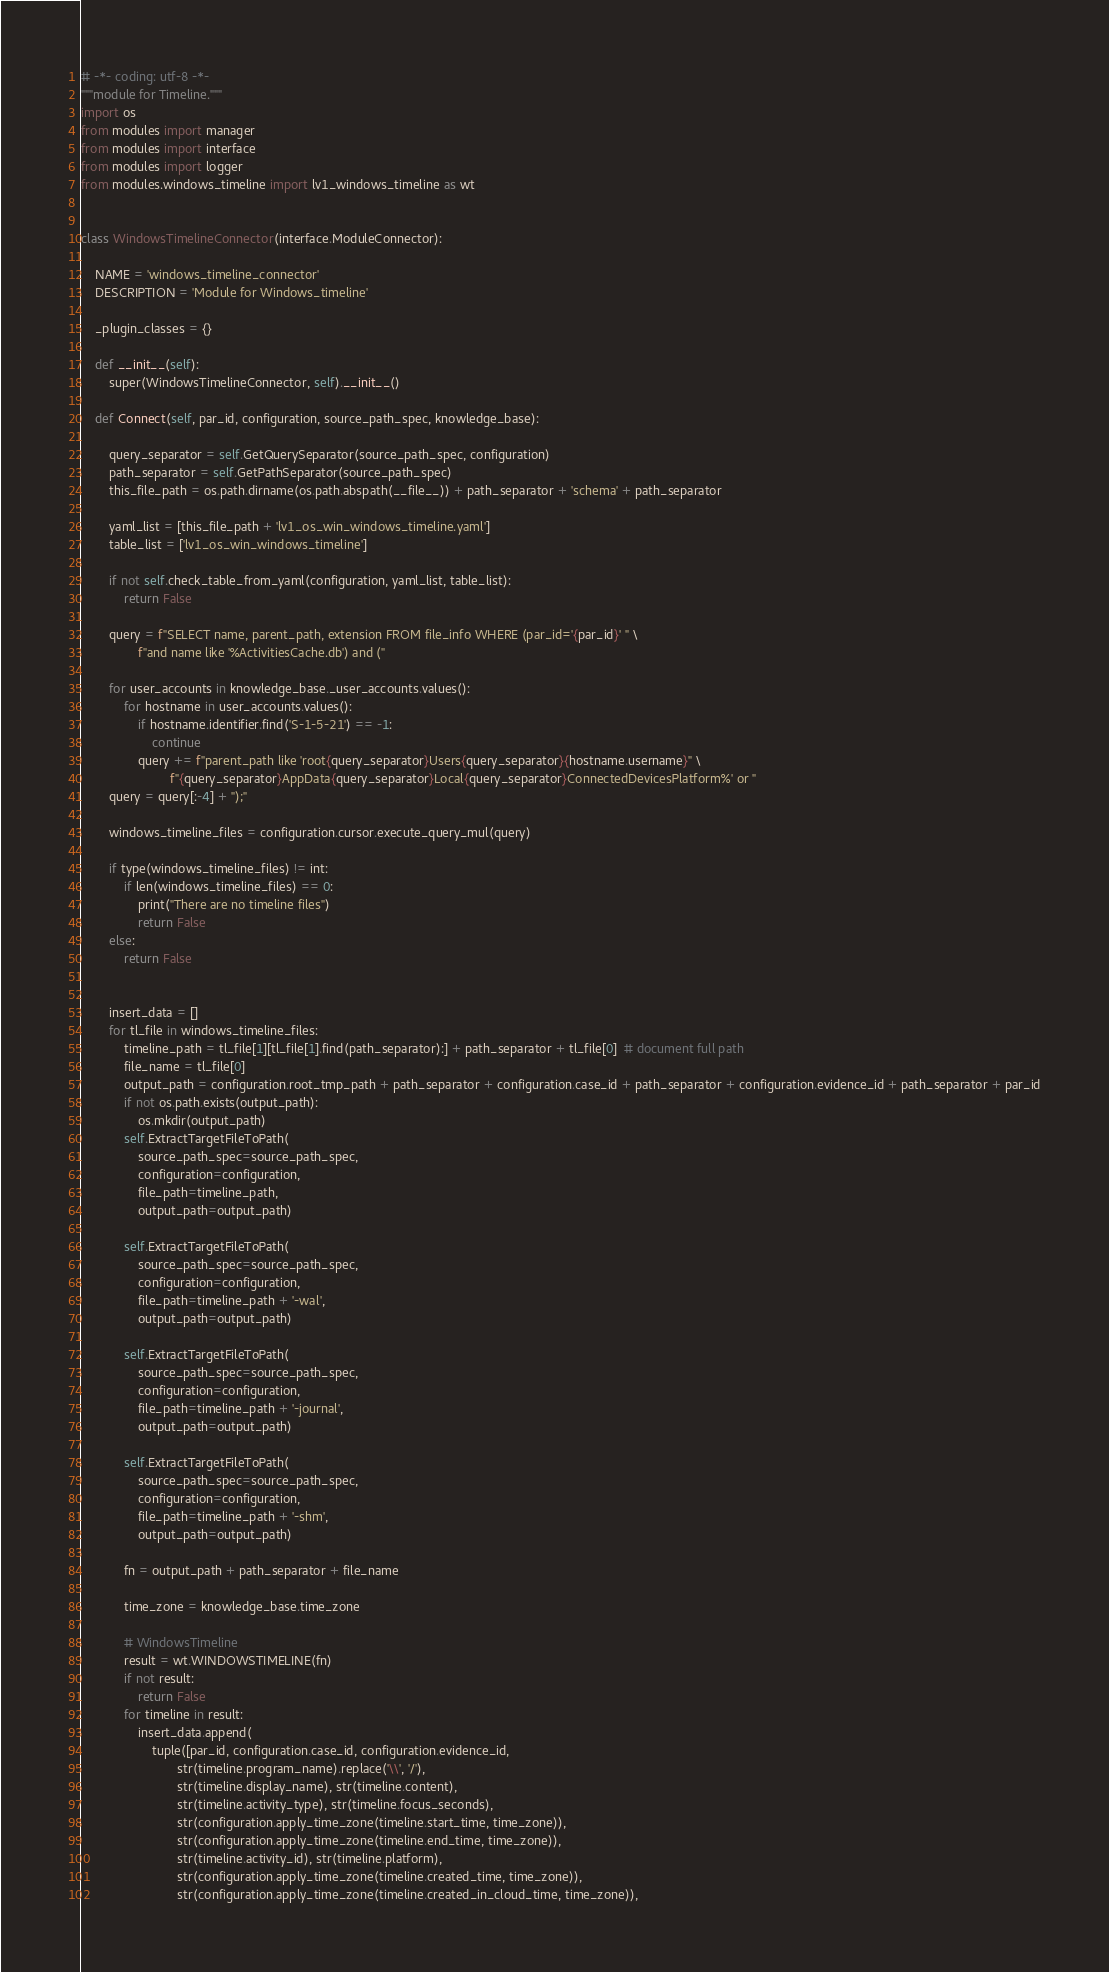Convert code to text. <code><loc_0><loc_0><loc_500><loc_500><_Python_># -*- coding: utf-8 -*-
"""module for Timeline."""
import os
from modules import manager
from modules import interface
from modules import logger
from modules.windows_timeline import lv1_windows_timeline as wt


class WindowsTimelineConnector(interface.ModuleConnector):

    NAME = 'windows_timeline_connector'
    DESCRIPTION = 'Module for Windows_timeline'

    _plugin_classes = {}

    def __init__(self):
        super(WindowsTimelineConnector, self).__init__()

    def Connect(self, par_id, configuration, source_path_spec, knowledge_base):

        query_separator = self.GetQuerySeparator(source_path_spec, configuration)
        path_separator = self.GetPathSeparator(source_path_spec)
        this_file_path = os.path.dirname(os.path.abspath(__file__)) + path_separator + 'schema' + path_separator

        yaml_list = [this_file_path + 'lv1_os_win_windows_timeline.yaml']
        table_list = ['lv1_os_win_windows_timeline']

        if not self.check_table_from_yaml(configuration, yaml_list, table_list):
            return False

        query = f"SELECT name, parent_path, extension FROM file_info WHERE (par_id='{par_id}' " \
                f"and name like '%ActivitiesCache.db') and ("

        for user_accounts in knowledge_base._user_accounts.values():
            for hostname in user_accounts.values():
                if hostname.identifier.find('S-1-5-21') == -1:
                    continue
                query += f"parent_path like 'root{query_separator}Users{query_separator}{hostname.username}" \
                         f"{query_separator}AppData{query_separator}Local{query_separator}ConnectedDevicesPlatform%' or "
        query = query[:-4] + ");"

        windows_timeline_files = configuration.cursor.execute_query_mul(query)

        if type(windows_timeline_files) != int:
            if len(windows_timeline_files) == 0:
                print("There are no timeline files")
                return False
        else:
            return False


        insert_data = []
        for tl_file in windows_timeline_files:
            timeline_path = tl_file[1][tl_file[1].find(path_separator):] + path_separator + tl_file[0]  # document full path
            file_name = tl_file[0]
            output_path = configuration.root_tmp_path + path_separator + configuration.case_id + path_separator + configuration.evidence_id + path_separator + par_id
            if not os.path.exists(output_path):
                os.mkdir(output_path)
            self.ExtractTargetFileToPath(
                source_path_spec=source_path_spec,
                configuration=configuration,
                file_path=timeline_path,
                output_path=output_path)

            self.ExtractTargetFileToPath(
                source_path_spec=source_path_spec,
                configuration=configuration,
                file_path=timeline_path + '-wal',
                output_path=output_path)

            self.ExtractTargetFileToPath(
                source_path_spec=source_path_spec,
                configuration=configuration,
                file_path=timeline_path + '-journal',
                output_path=output_path)

            self.ExtractTargetFileToPath(
                source_path_spec=source_path_spec,
                configuration=configuration,
                file_path=timeline_path + '-shm',
                output_path=output_path)

            fn = output_path + path_separator + file_name

            time_zone = knowledge_base.time_zone

            # WindowsTimeline
            result = wt.WINDOWSTIMELINE(fn)
            if not result:
                return False
            for timeline in result:
                insert_data.append(
                    tuple([par_id, configuration.case_id, configuration.evidence_id,
                           str(timeline.program_name).replace('\\', '/'),
                           str(timeline.display_name), str(timeline.content),
                           str(timeline.activity_type), str(timeline.focus_seconds),
                           str(configuration.apply_time_zone(timeline.start_time, time_zone)),
                           str(configuration.apply_time_zone(timeline.end_time, time_zone)),
                           str(timeline.activity_id), str(timeline.platform),
                           str(configuration.apply_time_zone(timeline.created_time, time_zone)),
                           str(configuration.apply_time_zone(timeline.created_in_cloud_time, time_zone)),</code> 